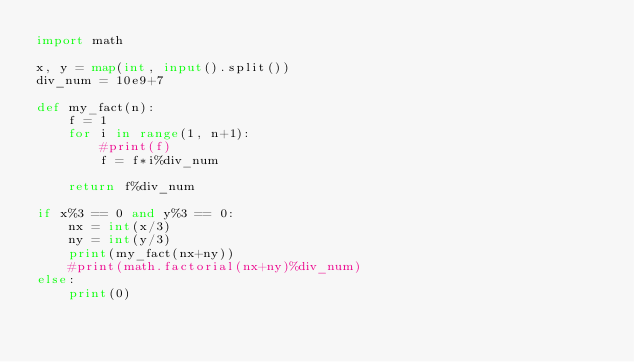<code> <loc_0><loc_0><loc_500><loc_500><_Python_>import math

x, y = map(int, input().split())
div_num = 10e9+7

def my_fact(n):
    f = 1
    for i in range(1, n+1):
        #print(f)
        f = f*i%div_num

    return f%div_num

if x%3 == 0 and y%3 == 0:
    nx = int(x/3)
    ny = int(y/3)
    print(my_fact(nx+ny))
    #print(math.factorial(nx+ny)%div_num)
else:
    print(0)</code> 